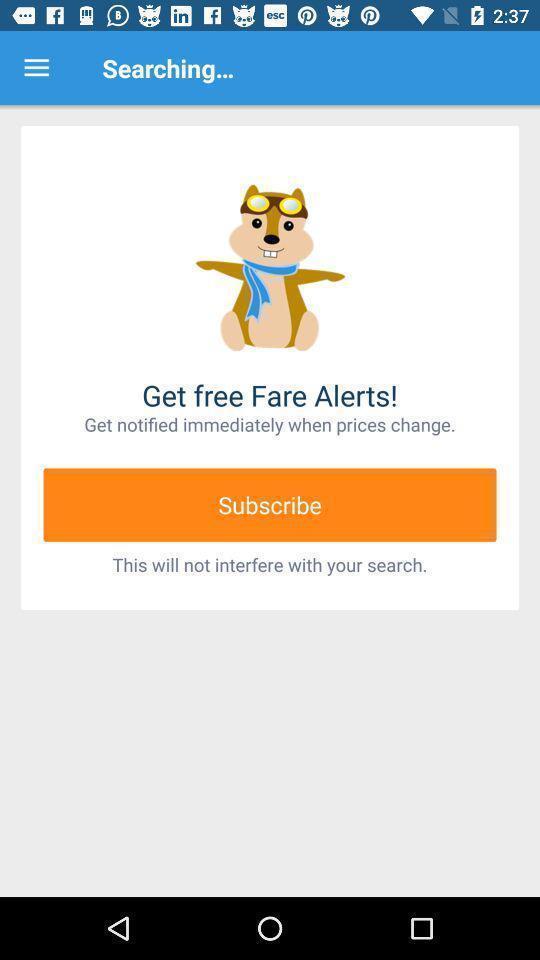Describe the content in this image. Searching page of the image. 